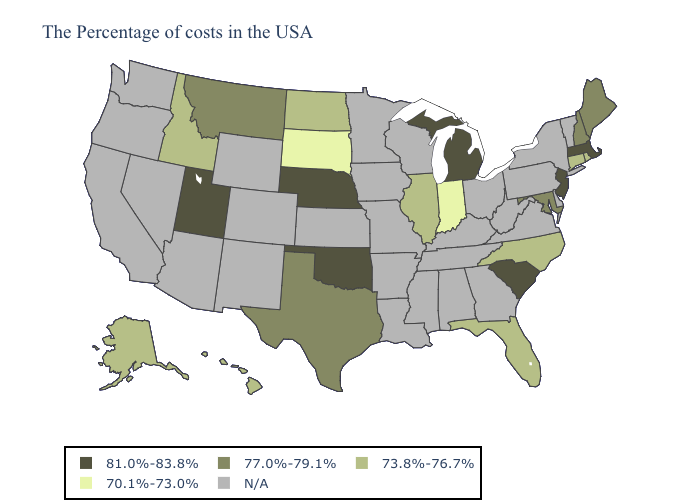Name the states that have a value in the range N/A?
Concise answer only. Vermont, New York, Delaware, Pennsylvania, Virginia, West Virginia, Ohio, Georgia, Kentucky, Alabama, Tennessee, Wisconsin, Mississippi, Louisiana, Missouri, Arkansas, Minnesota, Iowa, Kansas, Wyoming, Colorado, New Mexico, Arizona, Nevada, California, Washington, Oregon. Name the states that have a value in the range 73.8%-76.7%?
Be succinct. Rhode Island, Connecticut, North Carolina, Florida, Illinois, North Dakota, Idaho, Alaska, Hawaii. Name the states that have a value in the range 77.0%-79.1%?
Give a very brief answer. Maine, New Hampshire, Maryland, Texas, Montana. Among the states that border Louisiana , which have the lowest value?
Be succinct. Texas. What is the value of Wyoming?
Concise answer only. N/A. What is the value of Nevada?
Answer briefly. N/A. Which states hav the highest value in the South?
Keep it brief. South Carolina, Oklahoma. Name the states that have a value in the range 70.1%-73.0%?
Quick response, please. Indiana, South Dakota. Does Utah have the highest value in the West?
Write a very short answer. Yes. What is the value of Louisiana?
Quick response, please. N/A. What is the lowest value in the Northeast?
Answer briefly. 73.8%-76.7%. Which states hav the highest value in the South?
Give a very brief answer. South Carolina, Oklahoma. Is the legend a continuous bar?
Keep it brief. No. What is the value of New Hampshire?
Answer briefly. 77.0%-79.1%. Name the states that have a value in the range 77.0%-79.1%?
Keep it brief. Maine, New Hampshire, Maryland, Texas, Montana. 